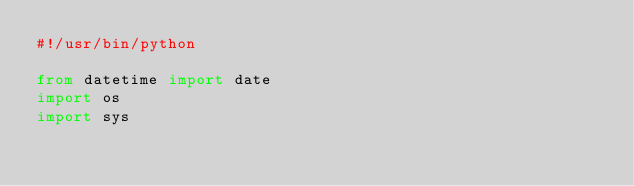Convert code to text. <code><loc_0><loc_0><loc_500><loc_500><_Python_>#!/usr/bin/python

from datetime import date
import os
import sys
</code> 